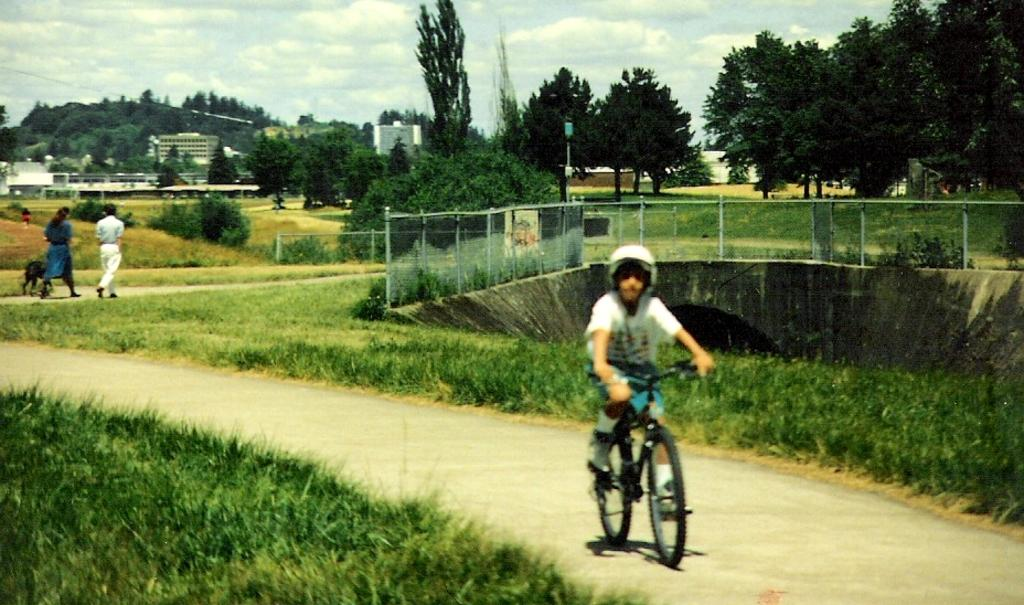What is the boy in the image doing? The boy is riding a bicycle in the image. What safety precaution is the boy taking while riding the bicycle? The boy is wearing a helmet. What are the couple in the image doing? The couple is walking in the image. Can you describe any other living creature in the image? There is a dog in the background of the image. What type of boats can be seen in the image? There are no boats present in the image. What is the name of the boy's daughter in the image? There is no mention of a daughter in the image. 